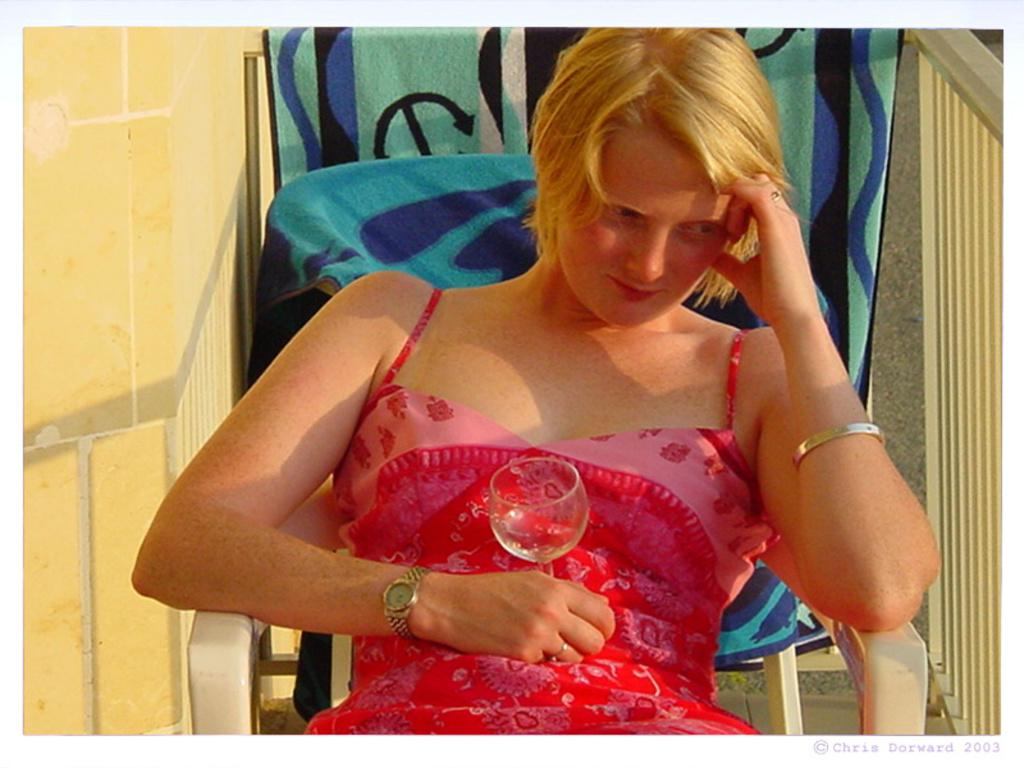What is the person in the image doing? The person is sitting on a chair in the image. What can be seen in the background of the image? There is a railing and a wall in the background of the image. What type of toothpaste is the person using in the image? There is no toothpaste present in the image; the person is sitting on a chair. Who is the father of the person in the image? The provided facts do not mention any family members, so it is not possible to determine the person's father from the image. 